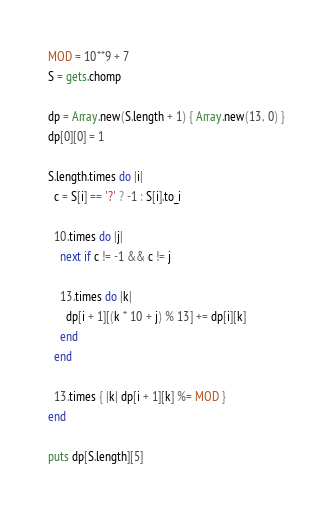<code> <loc_0><loc_0><loc_500><loc_500><_Ruby_>MOD = 10**9 + 7
S = gets.chomp

dp = Array.new(S.length + 1) { Array.new(13, 0) }
dp[0][0] = 1

S.length.times do |i|
  c = S[i] == '?' ? -1 : S[i].to_i

  10.times do |j|
    next if c != -1 && c != j

    13.times do |k|
      dp[i + 1][(k * 10 + j) % 13] += dp[i][k]
    end
  end

  13.times { |k| dp[i + 1][k] %= MOD }
end

puts dp[S.length][5]
</code> 